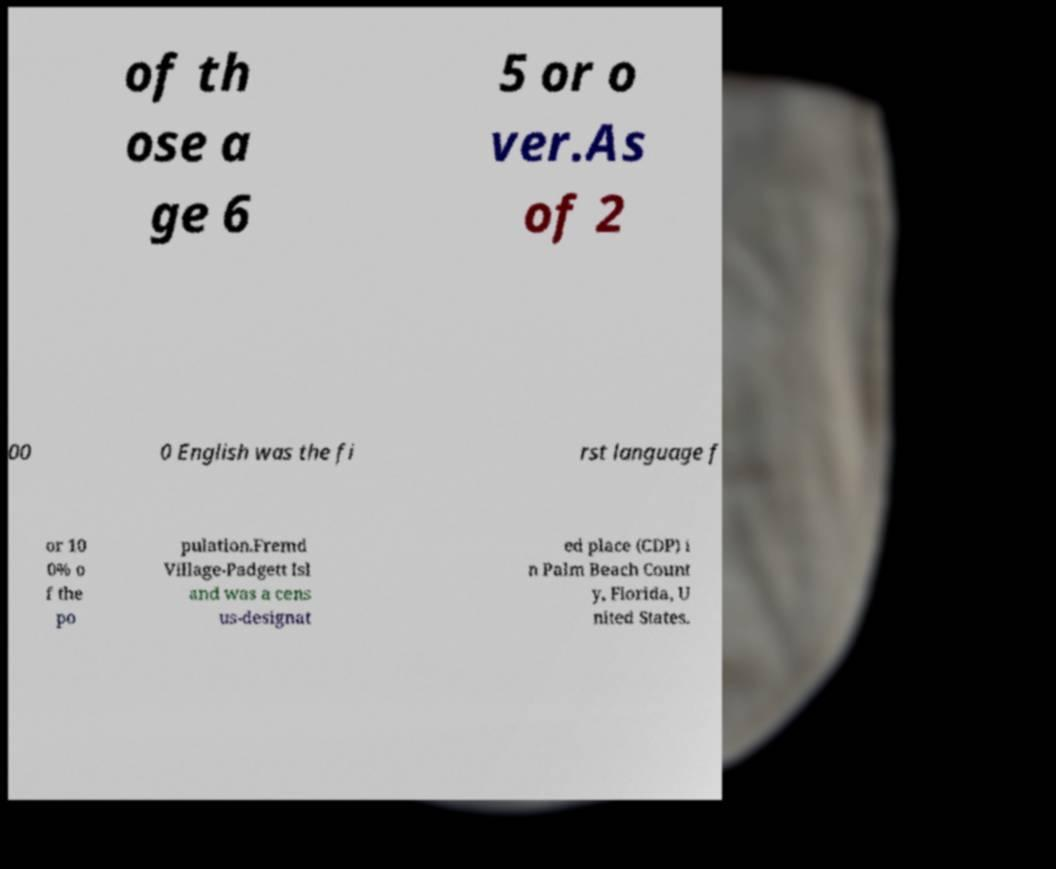Please read and relay the text visible in this image. What does it say? of th ose a ge 6 5 or o ver.As of 2 00 0 English was the fi rst language f or 10 0% o f the po pulation.Fremd Village-Padgett Isl and was a cens us-designat ed place (CDP) i n Palm Beach Count y, Florida, U nited States. 